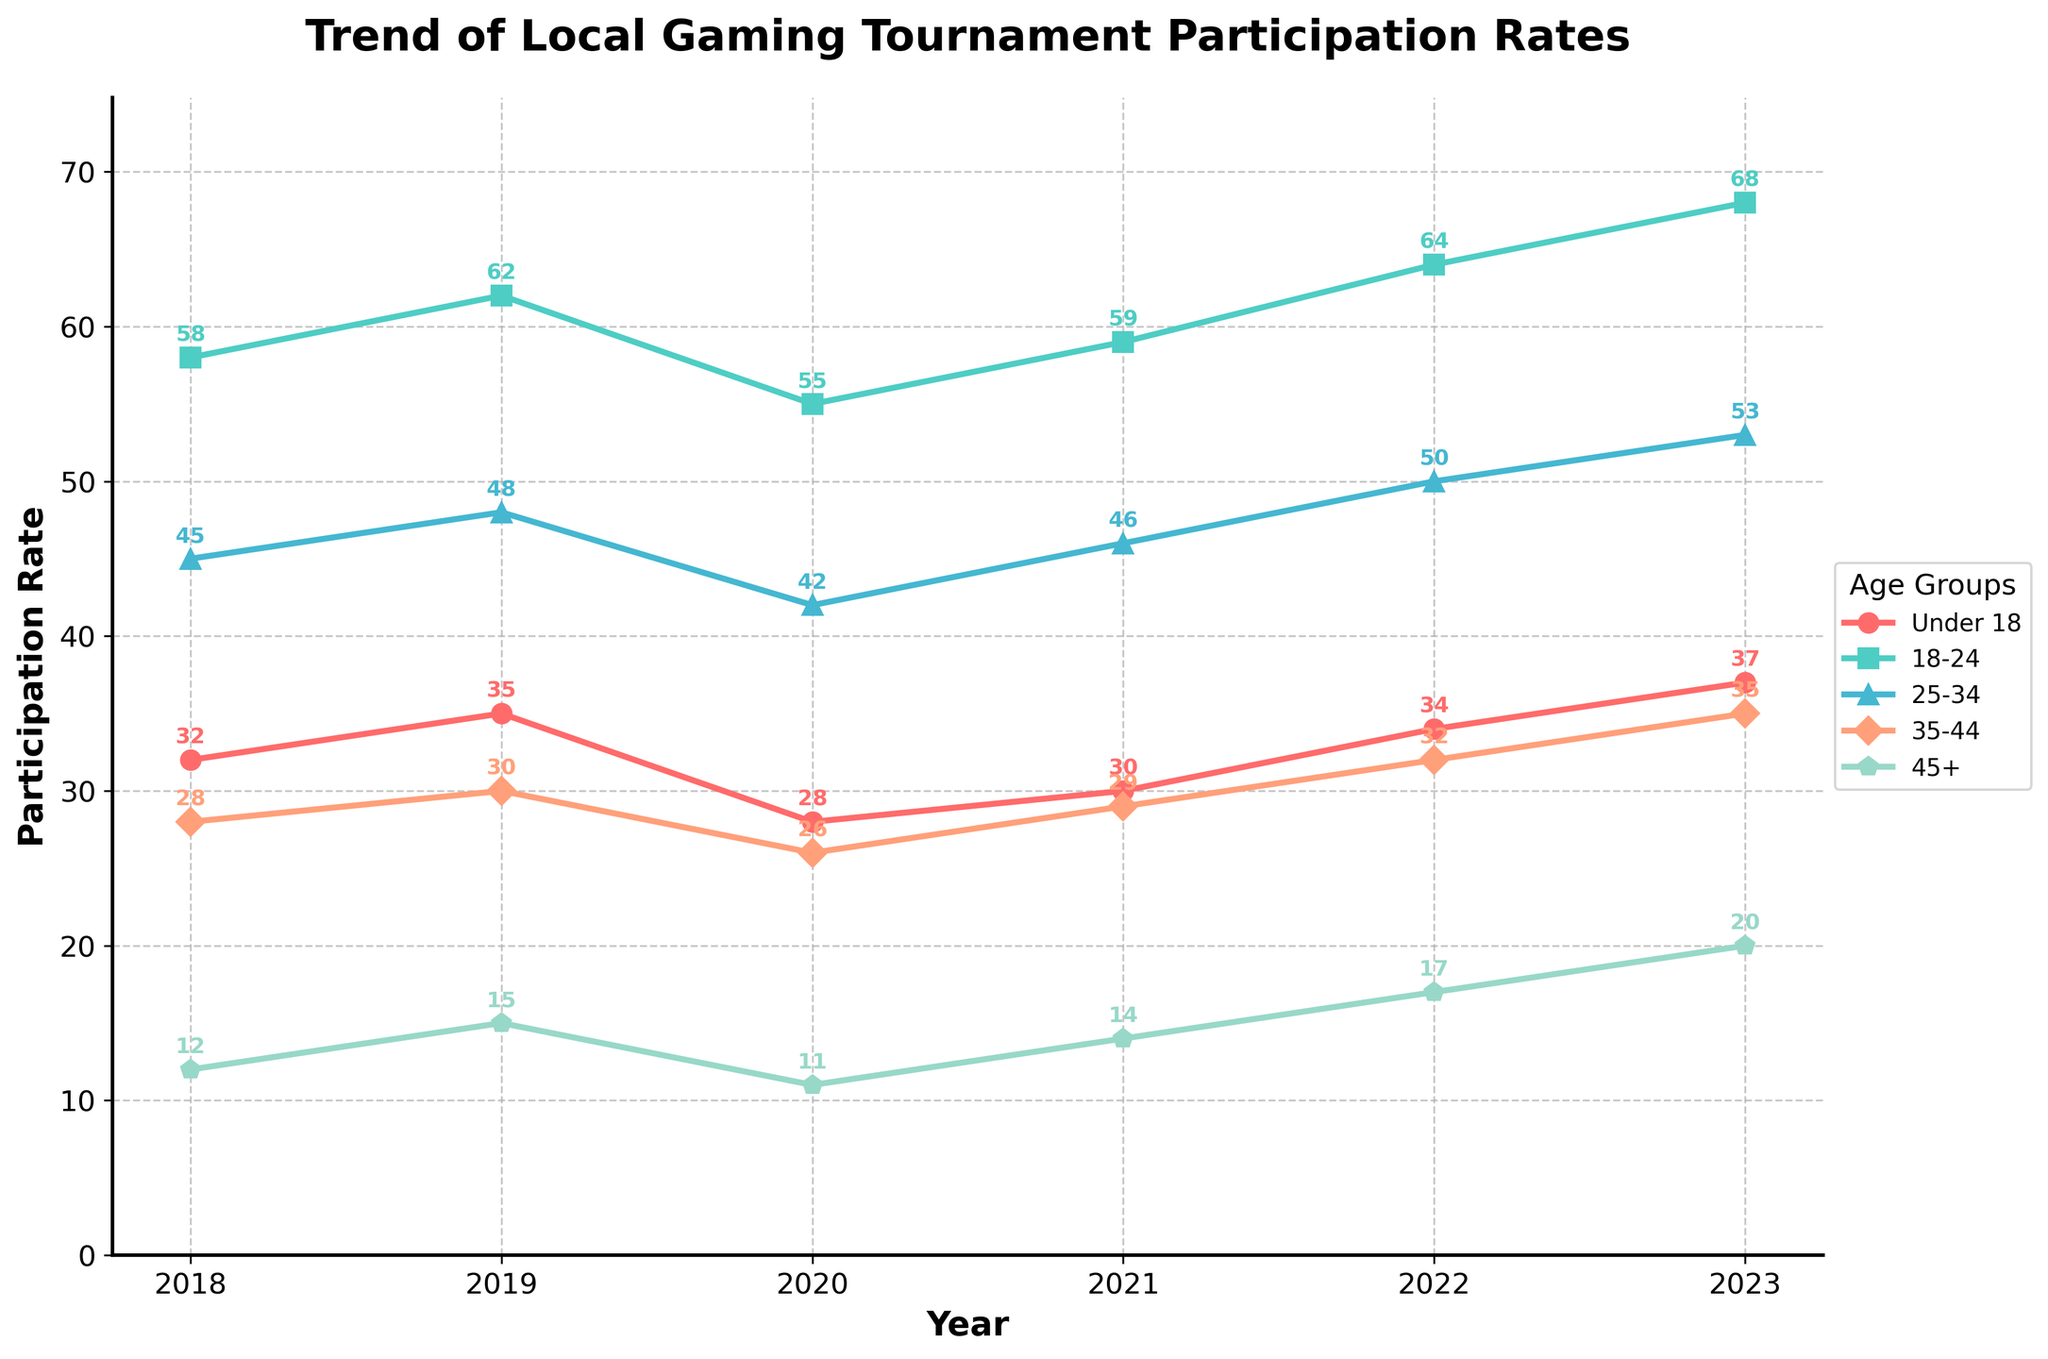Which age group had the highest participation rate in 2023? By referring to the figure, we can see that the "18-24" age group has the highest participation rate among all groups in 2023, at 68.
Answer: 18-24 What was the change in participation rate for the 25-34 age group from 2018 to 2023? The participation rate for the 25-34 age group in 2018 was 45, and in 2023 it was 53. The change is calculated as 53 - 45.
Answer: 8 Which age group showed the most steady participation rate over the years? Looking at the lines for each age group, the "45+" group shows the least fluctuation compared to other age groups.
Answer: 45+ Which age group had the biggest increase in participation rates from 2021 to 2023? Comparing the 2021 and 2023 participation rates for each age group, the "45+" group showed the biggest increase, going from 14 to 20. The increase can be calculated as 20 - 14.
Answer: 45+ Which year had the lowest overall participation rates for the "Under 18" age group? By inspecting the line for the "Under 18" group, we can see that the lowest participation rate was in 2020, at 28.
Answer: 2020 How did the participation rate of the 35-44 age group in 2022 compare to that in 2020? For the 35-44 age group, the participation rate in 2020 was 26 and in 2022 it was 32. We compare these by calculating 32 - 26.
Answer: 6 Which color represents the 25-34 age group in the figure? Examining the legend and the lines, we can see that the "25-34" age group is represented by a blue line.
Answer: Blue During which year did the 18-24 age group cross the 60-participation-rate threshold? Observing the line for the "18-24" group, the participation rate first reached above 60 in 2019.
Answer: 2019 What's the average participation rate for the "Under 18" group over these 6 years? Sum the participation rates for "Under 18" over 6 years (32 + 35 + 28 + 30 + 34 + 37) = 196, then divide by 6. So, the average is 196 / 6.
Answer: 32.67 